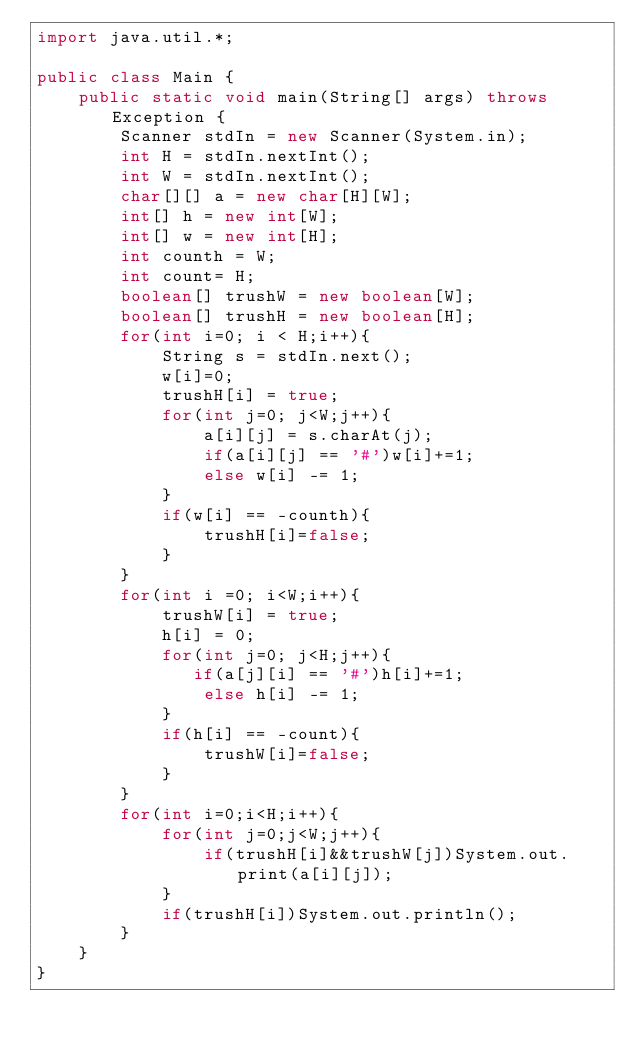Convert code to text. <code><loc_0><loc_0><loc_500><loc_500><_Java_>import java.util.*;

public class Main {
    public static void main(String[] args) throws Exception {
        Scanner stdIn = new Scanner(System.in);
        int H = stdIn.nextInt();
        int W = stdIn.nextInt();
        char[][] a = new char[H][W];
        int[] h = new int[W];
        int[] w = new int[H];
        int counth = W;
        int count= H;
        boolean[] trushW = new boolean[W];
        boolean[] trushH = new boolean[H];
        for(int i=0; i < H;i++){
            String s = stdIn.next();
            w[i]=0;
            trushH[i] = true;
            for(int j=0; j<W;j++){
                a[i][j] = s.charAt(j);
                if(a[i][j] == '#')w[i]+=1;
                else w[i] -= 1;
            }
            if(w[i] == -counth){
                trushH[i]=false;
            }
        }
        for(int i =0; i<W;i++){
            trushW[i] = true;
            h[i] = 0;
            for(int j=0; j<H;j++){
               if(a[j][i] == '#')h[i]+=1;
                else h[i] -= 1; 
            }
            if(h[i] == -count){
                trushW[i]=false;
            }
        }
        for(int i=0;i<H;i++){
            for(int j=0;j<W;j++){
                if(trushH[i]&&trushW[j])System.out.print(a[i][j]);
            }
            if(trushH[i])System.out.println();
        }
    }
}
</code> 